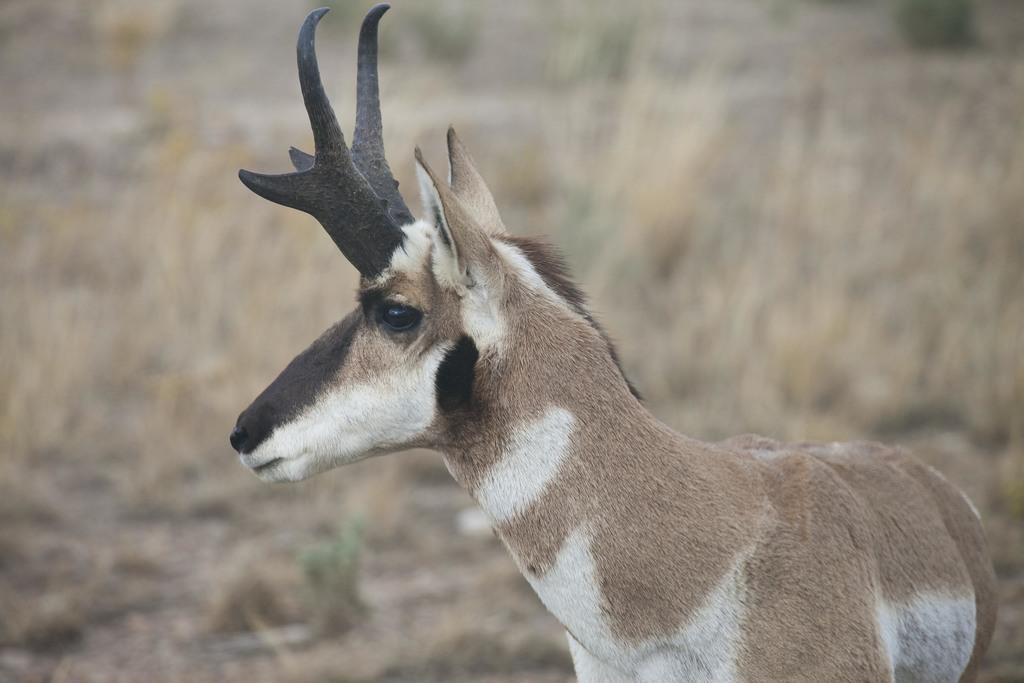Can you describe this image briefly? In this picture I can see there is a reindeer standing here on the ground and there is grass all over the floor and there are trees in the backdrop. 